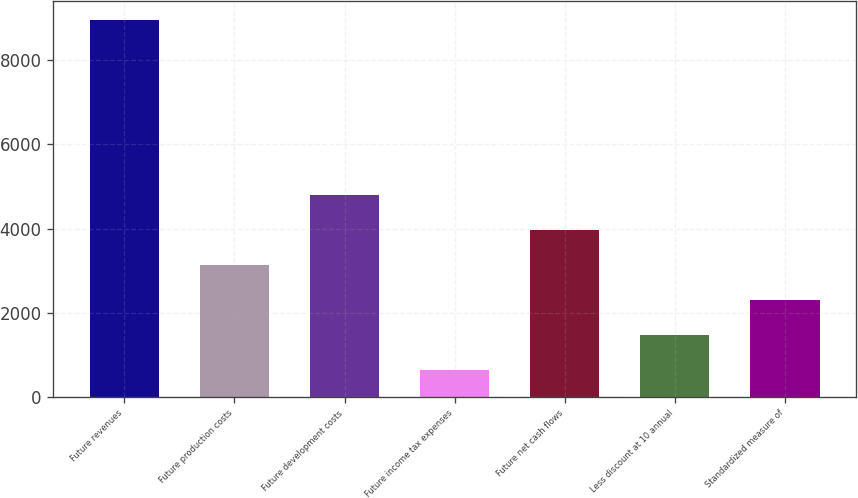<chart> <loc_0><loc_0><loc_500><loc_500><bar_chart><fcel>Future revenues<fcel>Future production costs<fcel>Future development costs<fcel>Future income tax expenses<fcel>Future net cash flows<fcel>Less discount at 10 annual<fcel>Standardized measure of<nl><fcel>8956<fcel>3142.5<fcel>4803.5<fcel>651<fcel>3973<fcel>1481.5<fcel>2312<nl></chart> 